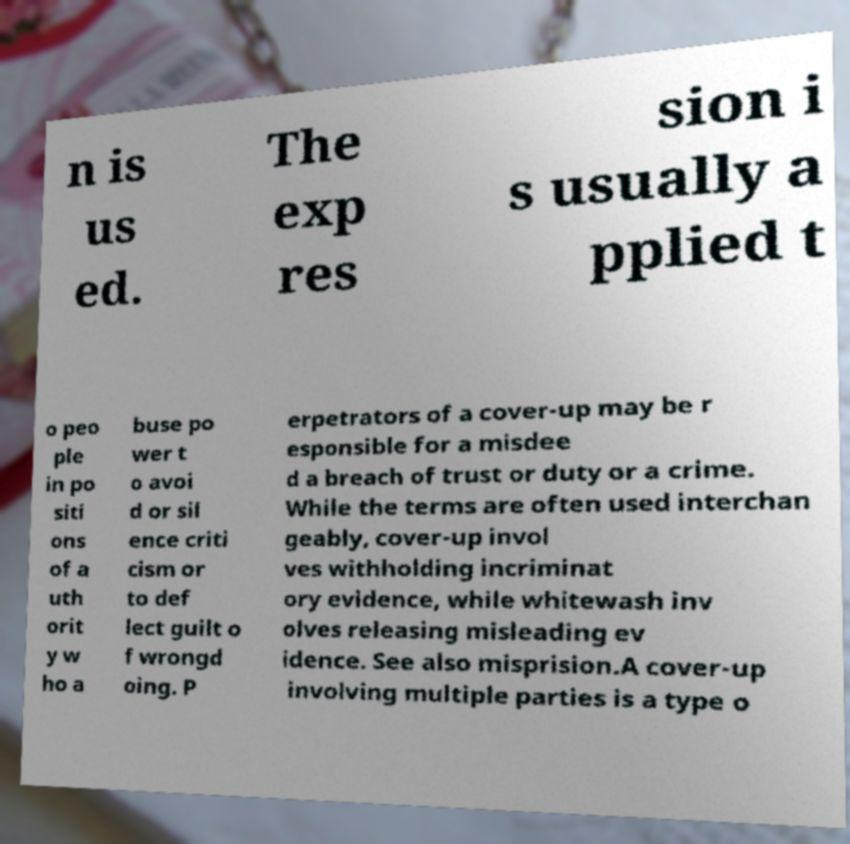Please read and relay the text visible in this image. What does it say? n is us ed. The exp res sion i s usually a pplied t o peo ple in po siti ons of a uth orit y w ho a buse po wer t o avoi d or sil ence criti cism or to def lect guilt o f wrongd oing. P erpetrators of a cover-up may be r esponsible for a misdee d a breach of trust or duty or a crime. While the terms are often used interchan geably, cover-up invol ves withholding incriminat ory evidence, while whitewash inv olves releasing misleading ev idence. See also misprision.A cover-up involving multiple parties is a type o 